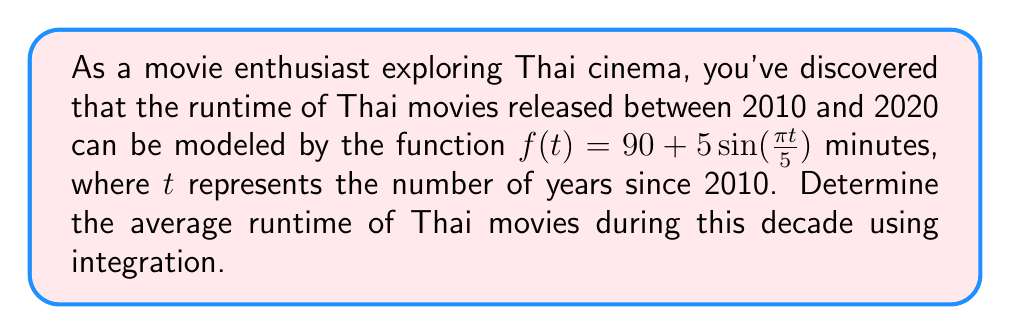Can you solve this math problem? To find the average runtime, we need to calculate the integral of the function over the given time period and divide it by the length of the period.

Step 1: Set up the integral for the average value
$$\text{Average} = \frac{1}{b-a}\int_{a}^{b} f(t) dt$$
where $a=0$ (2010) and $b=10$ (2020)

Step 2: Substitute the function and limits
$$\text{Average} = \frac{1}{10}\int_{0}^{10} (90 + 5\sin(\frac{\pi t}{5})) dt$$

Step 3: Split the integral
$$\text{Average} = \frac{1}{10}\left[\int_{0}^{10} 90 dt + \int_{0}^{10} 5\sin(\frac{\pi t}{5}) dt\right]$$

Step 4: Evaluate the first integral
$$\int_{0}^{10} 90 dt = 90t\bigg|_{0}^{10} = 900$$

Step 5: Evaluate the second integral using u-substitution
Let $u = \frac{\pi t}{5}$, then $du = \frac{\pi}{5}dt$ and $dt = \frac{5}{\pi}du$
$$\int_{0}^{10} 5\sin(\frac{\pi t}{5}) dt = \frac{25}{\pi}\int_{0}^{2\pi} \sin(u) du = \frac{25}{\pi}[-\cos(u)]\bigg|_{0}^{2\pi} = 0$$

Step 6: Combine the results
$$\text{Average} = \frac{1}{10}(900 + 0) = 90$$

Therefore, the average runtime of Thai movies during this decade is 90 minutes.
Answer: 90 minutes 